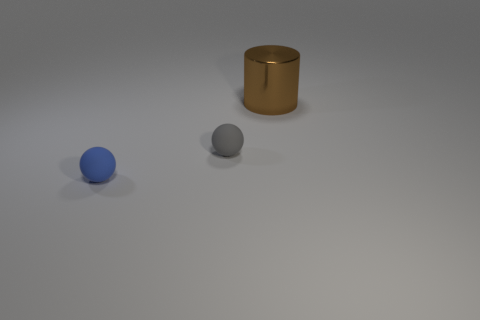The thing that is made of the same material as the gray ball is what shape?
Provide a succinct answer. Sphere. Is the number of tiny blue rubber balls to the left of the small blue rubber ball less than the number of red matte cubes?
Your answer should be very brief. No. Is the shape of the big brown metal object the same as the small gray thing?
Your answer should be very brief. No. How many shiny objects are either big brown cylinders or small blue spheres?
Make the answer very short. 1. Is there a blue shiny cube of the same size as the gray matte ball?
Give a very brief answer. No. How many rubber spheres have the same size as the gray matte thing?
Your response must be concise. 1. Do the rubber ball right of the blue sphere and the thing to the right of the small gray sphere have the same size?
Your response must be concise. No. How many things are either gray balls or tiny rubber things that are to the right of the blue sphere?
Your answer should be compact. 1. The big object has what color?
Keep it short and to the point. Brown. There is a tiny sphere behind the small sphere in front of the matte sphere that is behind the tiny blue ball; what is its material?
Offer a terse response. Rubber. 